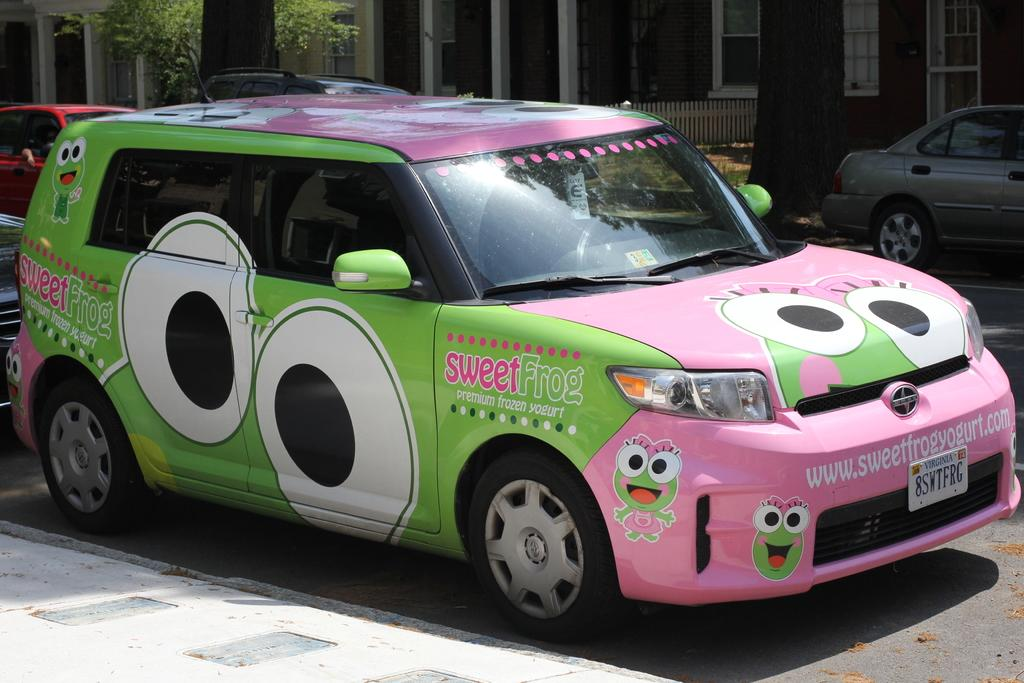What type of vehicles can be seen on the road in the image? There are cars on the road in the image. What can be seen in the background of the image? There is a metal fence, a tree, and buildings in the background of the image. What type of screw can be seen holding the coast together in the image? There is no coast or screw present in the image. 